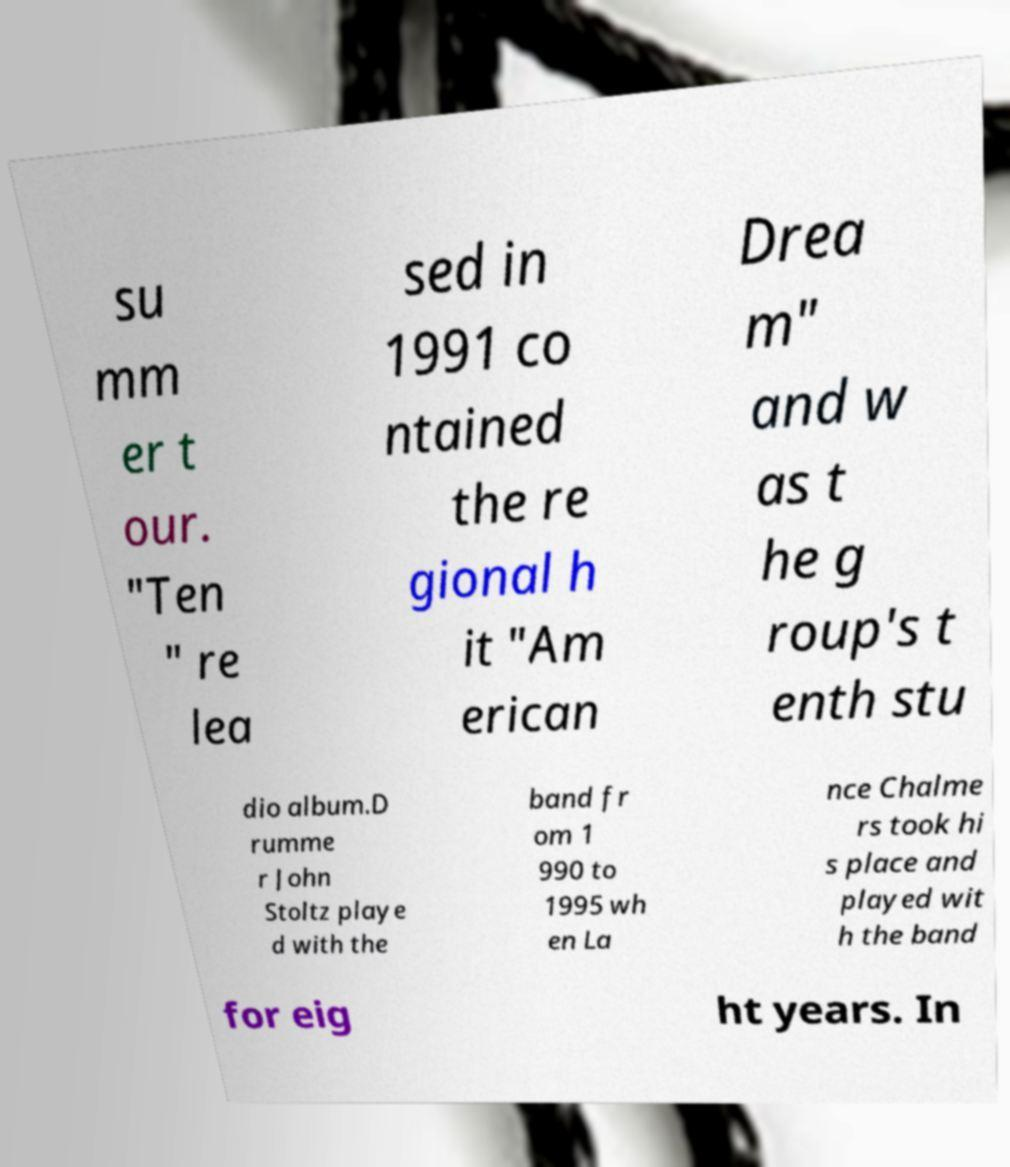There's text embedded in this image that I need extracted. Can you transcribe it verbatim? su mm er t our. "Ten " re lea sed in 1991 co ntained the re gional h it "Am erican Drea m" and w as t he g roup's t enth stu dio album.D rumme r John Stoltz playe d with the band fr om 1 990 to 1995 wh en La nce Chalme rs took hi s place and played wit h the band for eig ht years. In 